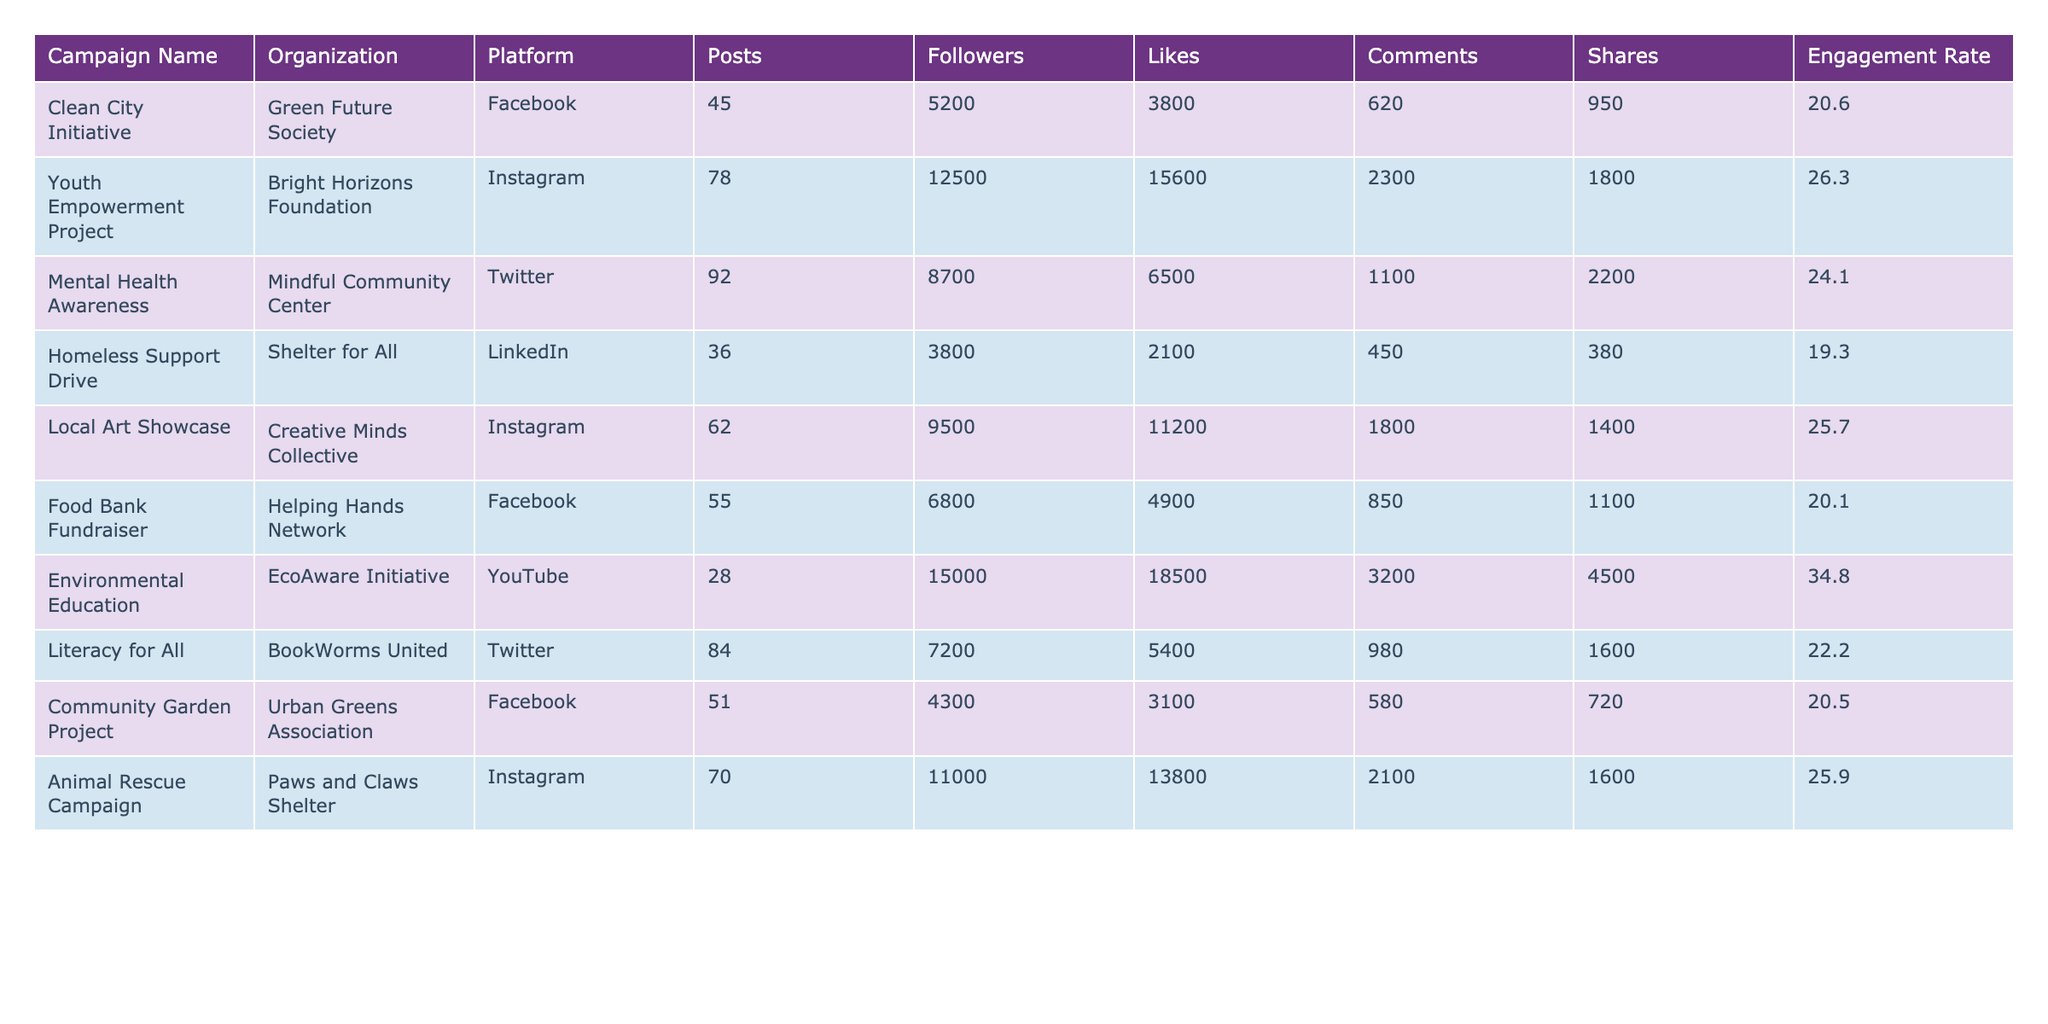What is the engagement rate for the "Food Bank Fundraiser" campaign? The table shows the engagement rate for each campaign, and for the "Food Bank Fundraiser," it is listed as 20.1%.
Answer: 20.1% Which organization ran the "Animal Rescue Campaign"? To find the organization associated with the "Animal Rescue Campaign," I look in the table and see that it is Paws and Claws Shelter.
Answer: Paws and Claws Shelter What is the average engagement rate across all campaigns listed in the table? I calculate the average engagement rate by first converting the engagement rates from percentages to decimals: (0.206 + 0.263 + 0.241 + 0.193 + 0.257 + 0.201 + 0.348 + 0.222 + 0.205 + 0.259) = 2.285. There are 10 campaigns, so the average is 2.285 / 10 = 0.2285 or 22.85%.
Answer: 22.85% Is the engagement rate for the "Youth Empowerment Project" higher than that for the "Mental Health Awareness" campaign? The engagement rate for the "Youth Empowerment Project" is 26.3%, while for "Mental Health Awareness," it is 24.1%. Since 26.3% is greater than 24.1%, the statement is true.
Answer: Yes Which platform had the highest engagement rate among the campaigns listed? I examine the engagement rates for each platform: Facebook (20.6%, 20.1%, 20.5%), Instagram (26.3%, 25.7%, 25.9%), Twitter (24.1%, 22.2%), LinkedIn (19.3%), and YouTube (34.8%). The highest engagement rate is 34.8% for the Environmental Education campaign on YouTube.
Answer: YouTube What is the total number of likes received across all campaigns? To find the total likes, I sum the likes for each campaign: 3800 + 15600 + 6500 + 2100 + 11200 + 4900 + 18500 + 5400 + 3100 + 13800 = 68600.
Answer: 68600 Are there any campaigns on Facebook with an engagement rate above 20%? The engagement rates for Facebook campaigns are 20.6%, 20.1%, and 20.5%. Since all three rates are above 20%, the answer is true.
Answer: Yes What is the difference in engagement rates between the "Clean City Initiative" and "Environmental Education" campaigns? The engagement rate for the "Clean City Initiative" is 20.6%, and for "Environmental Education," it is 34.8%. I calculate the difference: 34.8% - 20.6% = 14.2%.
Answer: 14.2% What percentage of the total posts were made by the "Local Art Showcase"? The total number of posts across all campaigns is 45 + 78 + 92 + 36 + 62 + 55 + 28 + 84 + 51 + 70 = 501. The posts for "Local Art Showcase" are 62. I calculate the percentage as (62 / 501) * 100 = 12.38%.
Answer: 12.38% Which organization had the lowest engagement rate and what was it? I check the engagement rates for all organizations: Green Future Society (20.6%), Bright Horizons Foundation (26.3%), Mindful Community Center (24.1%), Shelter for All (19.3%), Creative Minds Collective (25.7%), Helping Hands Network (20.1%), EcoAware Initiative (34.8%), BookWorms United (22.2%), Urban Greens Association (20.5%), and Paws and Claws Shelter (25.9%). The lowest engagement rate is 19.3% for Shelter for All.
Answer: Shelter for All, 19.3% 